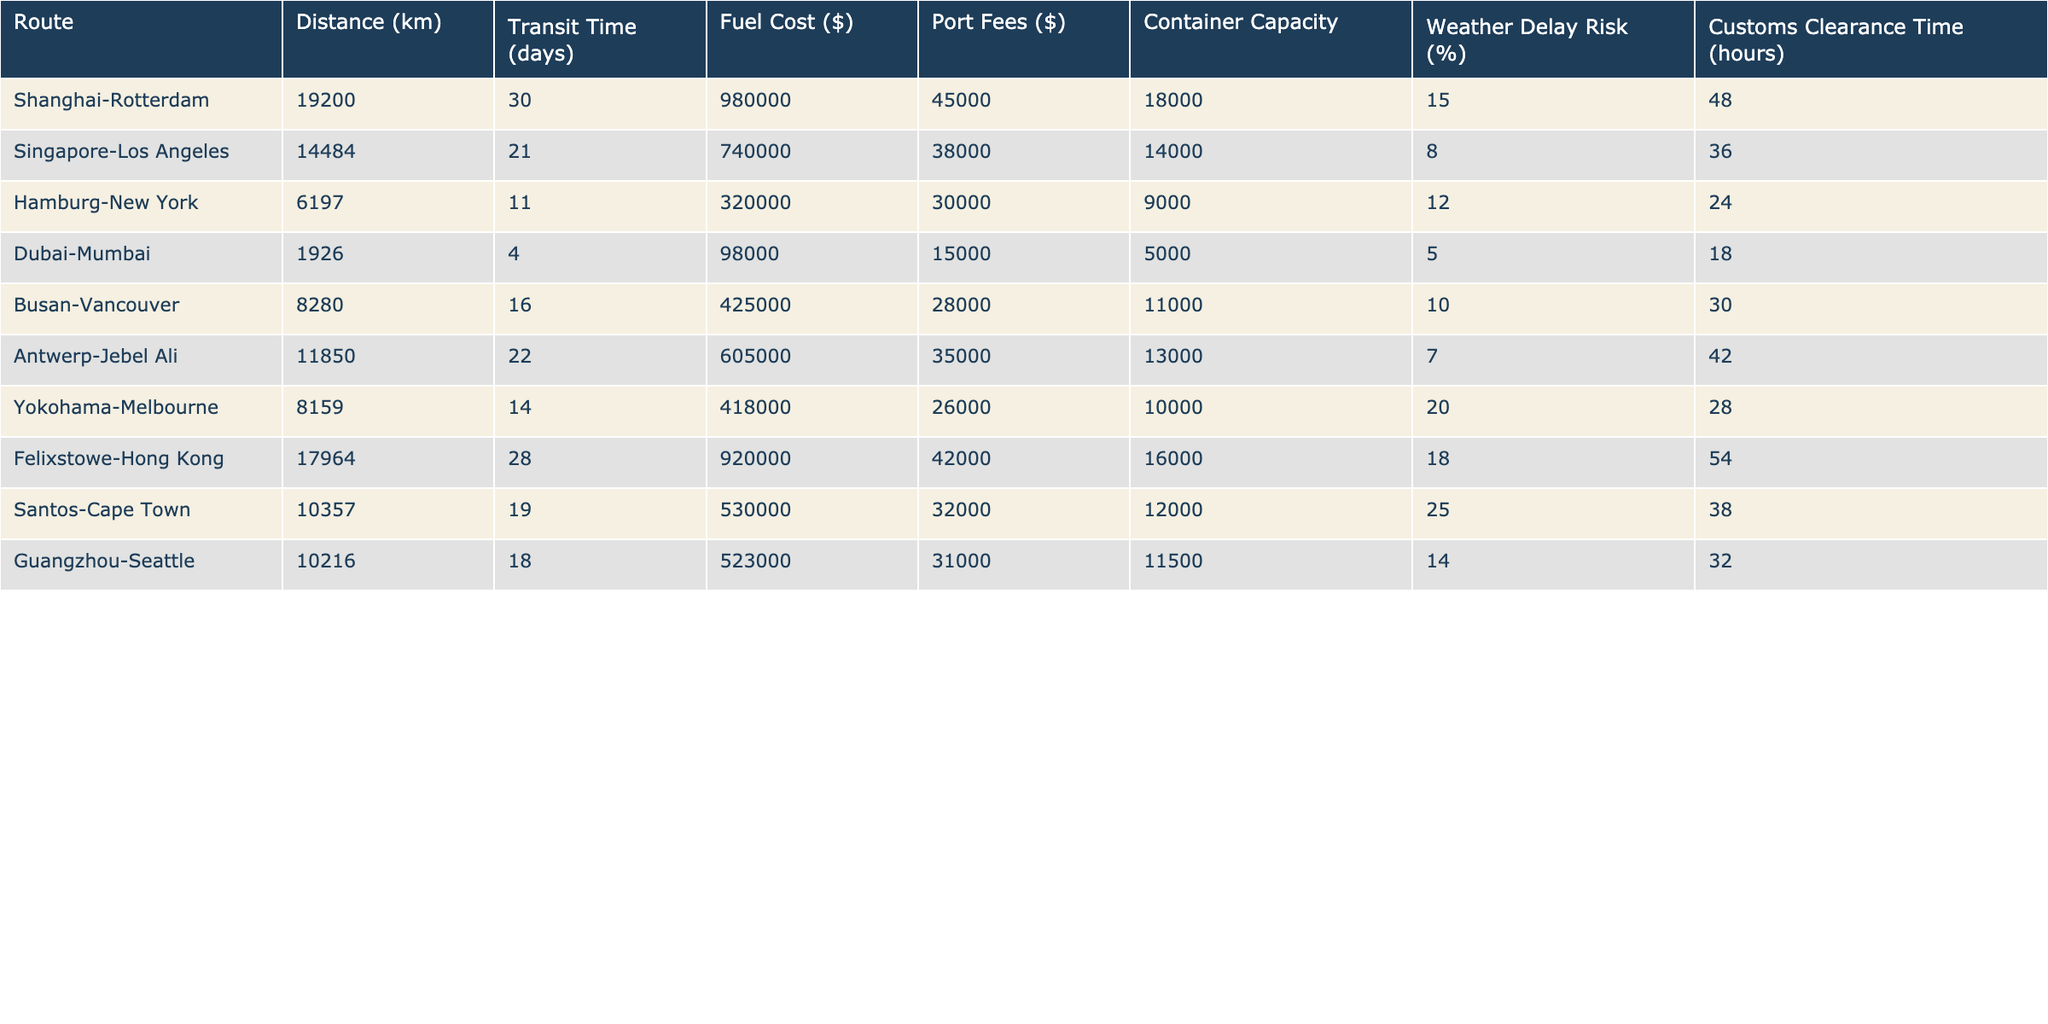What is the distance from Shanghai to Rotterdam? The table clearly lists the distance for the Shanghai-Rotterdam route as 19200 km.
Answer: 19200 km Which route has the highest fuel cost? By comparing the Fuel Cost values, the Felixstowe-Hong Kong route shows the highest cost at $920,000.
Answer: Felixstowe-Hong Kong What is the average transit time of all routes? Adding all the transit times (30, 21, 11, 4, 16, 22, 14, 28, 19, and 18) gives  30 + 21 + 11 + 4 + 16 + 22 + 14 + 28 + 19 + 18 =  263 days. There are 10 routes so, the average is 263 / 10 = 26.3 days.
Answer: 26.3 days Is the customs clearance time for the Hamburg-New York route greater than the average for all routes? The customs clearance times are 48, 36, 24, 18, 30, 42, 28, 54, 38, and 32 hours. The average is (48 + 36 + 24 + 18 + 30 + 42 + 28 + 54 + 38 + 32) / 10 = 34 hours. Since the Hamburg-New York customs clearance time is 24 hours, it is less than the average of 34 hours.
Answer: No Which route has the lowest weather delay risk? The lowest weather delay risk is 5%, associated with the Dubai-Mumbai route.
Answer: Dubai-Mumbai What is the total fuel cost of the routes that have a transit time of less than 15 days? The involved routes are Dubai-Mumbai ($98,000), Hamburg-New York ($320,000), and Busan-Vancouver ($425,000). Adding these amounts yields $98,000 + $320,000 + $425,000 = $843,000.
Answer: $843,000 Is the container capacity for the Singapore-Los Angeles route higher than that of the Yokohama-Melbourne route? The table lists the container capacity for Singapore-Los Angeles as 14,000 and Yokohama-Melbourne as 10,000. Therefore, 14,000 is greater than 10,000.
Answer: Yes What is the total distance of routes with a customs clearance time above 30 hours? The qualifying routes are Shanghai-Rotterdam (19200 km), Felixstowe-Hong Kong (17964 km), and Antwerp-Jebel Ali (11850 km). The total distance is 19200 + 17964 + 11850 = 49014 km.
Answer: 49014 km How does the fuel cost of the Antwerp-Jebel Ali route compare to the average fuel cost of all routes? The total fuel costs are $980,000, $740,000, $320,000, $98,000, $425,000, $605,000, $418,000, $920,000, $530,000, and $523,000, totaling $4,186,000. The average is $4,186,000 / 10 = $418,600. The cost for Antwerp-Jebel Ali is $605,000, which is higher than the average.
Answer: Higher What is the risk of weather delays for the route with the lowest container capacity? The route with the lowest container capacity is Dubai-Mumbai with a capacity of 5,000. The risk of weather delays for this route is 5%.
Answer: 5% 